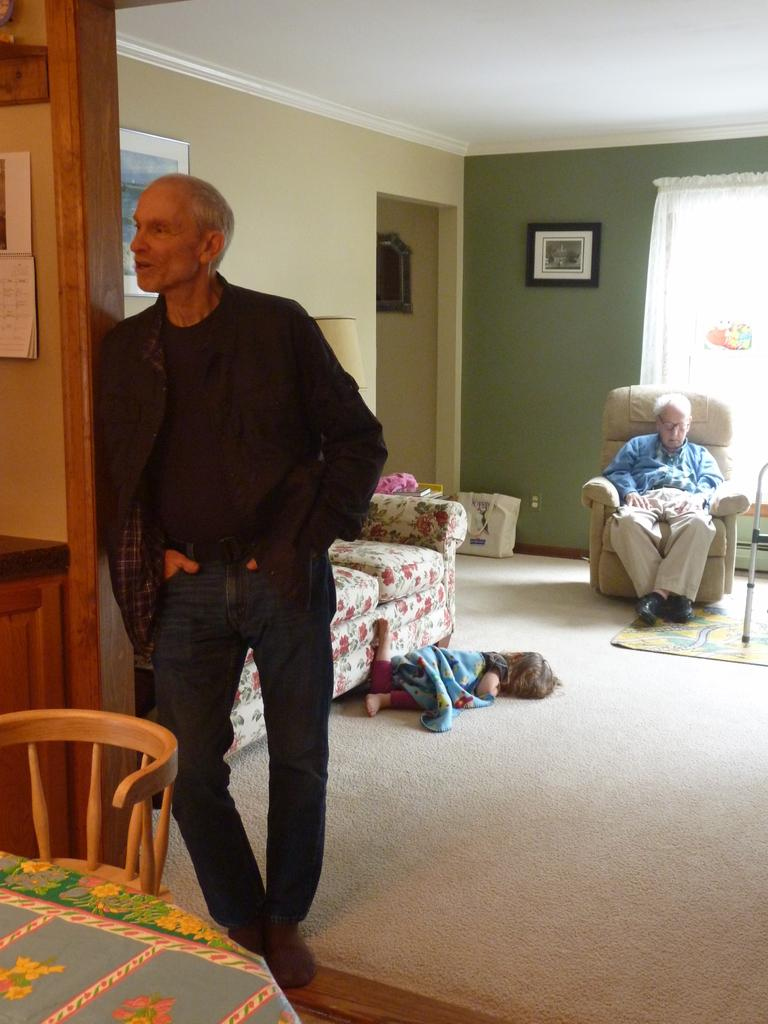How many people are present in the image? There are three people in the image: one standing, one laying on the floor, and one sitting on a chair. What is the position of the person sitting in the image? The person sitting in the image is on a chair. What type of furniture is on the floor in the image? There is a sofa on the floor in the image. What can be seen on the wall in the background of the image? There is a frame on the wall in the background of the image. What type of window treatment is present in the image? There is a curtain in the background of the image. What type of pest can be seen crawling on the person laying on the floor in the image? There are no pests visible in the image, and no pests are mentioned in the provided facts. 